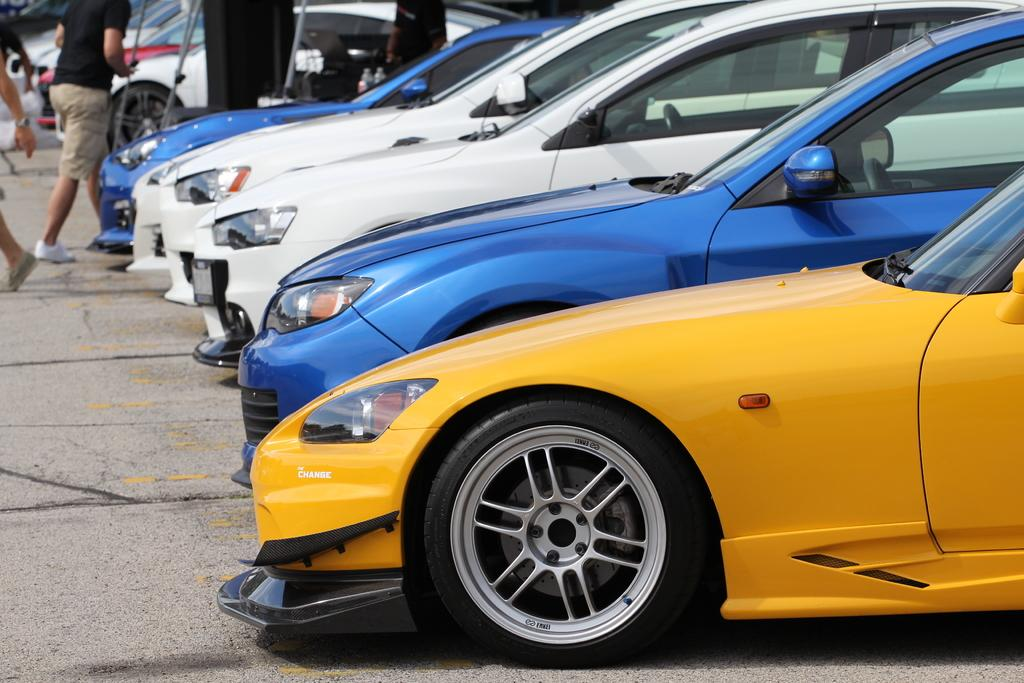What is the main subject in the center of the image? There are cars in the center of the image. What can be seen happening in the background of the image? There are persons walking in the background of the image. What type of swing can be seen near the ocean in the image? There is no swing or ocean present in the image; it only features cars and persons walking in the background. 